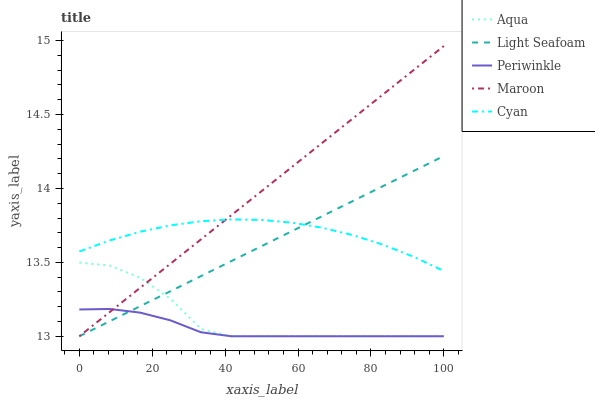Does Periwinkle have the minimum area under the curve?
Answer yes or no. Yes. Does Maroon have the maximum area under the curve?
Answer yes or no. Yes. Does Light Seafoam have the minimum area under the curve?
Answer yes or no. No. Does Light Seafoam have the maximum area under the curve?
Answer yes or no. No. Is Maroon the smoothest?
Answer yes or no. Yes. Is Aqua the roughest?
Answer yes or no. Yes. Is Light Seafoam the smoothest?
Answer yes or no. No. Is Light Seafoam the roughest?
Answer yes or no. No. Does Periwinkle have the lowest value?
Answer yes or no. Yes. Does Cyan have the lowest value?
Answer yes or no. No. Does Maroon have the highest value?
Answer yes or no. Yes. Does Light Seafoam have the highest value?
Answer yes or no. No. Is Periwinkle less than Cyan?
Answer yes or no. Yes. Is Cyan greater than Periwinkle?
Answer yes or no. Yes. Does Aqua intersect Maroon?
Answer yes or no. Yes. Is Aqua less than Maroon?
Answer yes or no. No. Is Aqua greater than Maroon?
Answer yes or no. No. Does Periwinkle intersect Cyan?
Answer yes or no. No. 